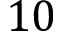<formula> <loc_0><loc_0><loc_500><loc_500>1 0</formula> 